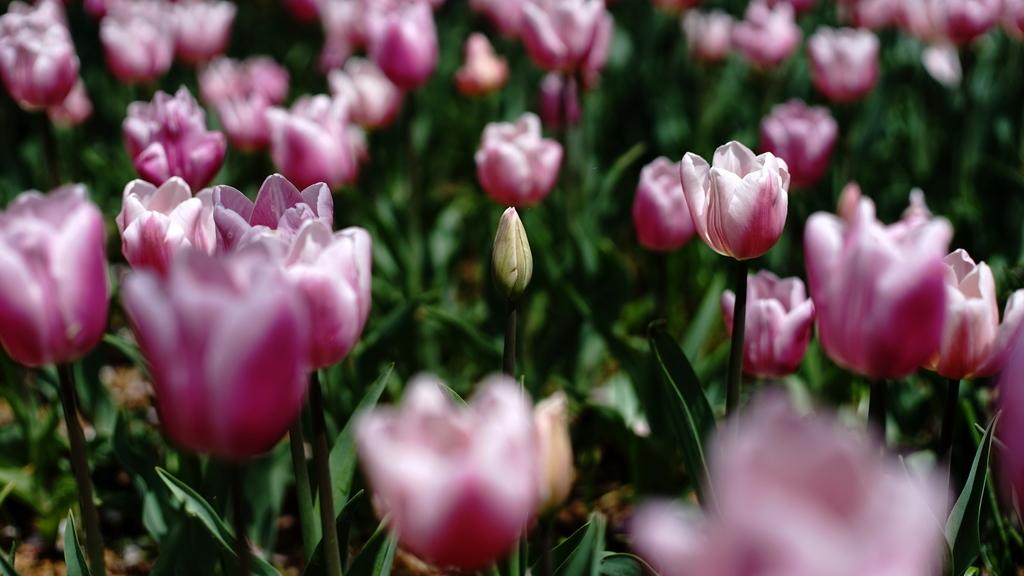What type of plants can be seen in the image? There are many tulip plants in the image. How many tulip plants are visible in the image? The number of tulip plants is not specified, but there are many of them. What is the color of the tulip plants in the image? The color of the tulip plants is not mentioned in the facts, so we cannot determine their color from the image. What type of credit card is being used to purchase the tulip plants in the image? There is no credit card or purchase activity depicted in the image; it only shows tulip plants. 